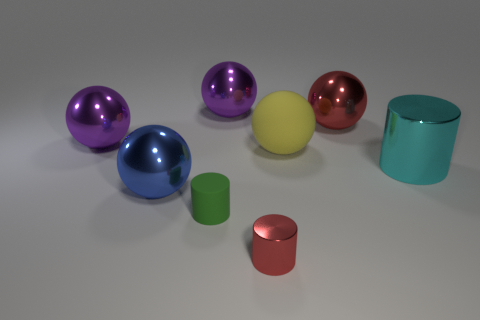Does the big red object have the same shape as the blue object?
Keep it short and to the point. Yes. There is a metal ball to the right of the metallic cylinder that is in front of the green thing; what color is it?
Your answer should be very brief. Red. There is a ball that is on the right side of the blue object and left of the large matte ball; how big is it?
Provide a succinct answer. Large. Are there any other things that have the same color as the matte ball?
Give a very brief answer. No. There is a blue thing that is the same material as the cyan object; what is its shape?
Provide a succinct answer. Sphere. Does the big yellow object have the same shape as the large purple object left of the blue metal sphere?
Offer a very short reply. Yes. What material is the tiny cylinder behind the small red cylinder in front of the yellow rubber sphere?
Your response must be concise. Rubber. Are there an equal number of spheres that are right of the green matte cylinder and green matte cylinders?
Make the answer very short. No. Is there any other thing that has the same material as the large blue thing?
Your response must be concise. Yes. There is a large rubber sphere behind the large blue ball; is it the same color as the sphere that is in front of the large cyan metallic thing?
Offer a very short reply. No. 